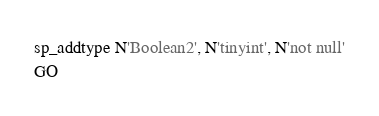Convert code to text. <code><loc_0><loc_0><loc_500><loc_500><_SQL_>sp_addtype N'Boolean2', N'tinyint', N'not null'
GO</code> 